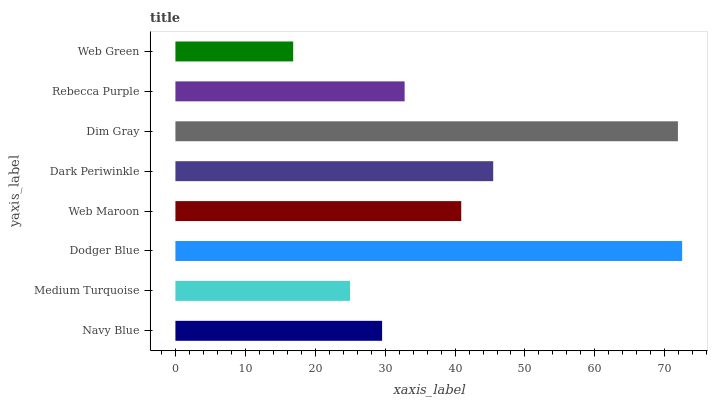Is Web Green the minimum?
Answer yes or no. Yes. Is Dodger Blue the maximum?
Answer yes or no. Yes. Is Medium Turquoise the minimum?
Answer yes or no. No. Is Medium Turquoise the maximum?
Answer yes or no. No. Is Navy Blue greater than Medium Turquoise?
Answer yes or no. Yes. Is Medium Turquoise less than Navy Blue?
Answer yes or no. Yes. Is Medium Turquoise greater than Navy Blue?
Answer yes or no. No. Is Navy Blue less than Medium Turquoise?
Answer yes or no. No. Is Web Maroon the high median?
Answer yes or no. Yes. Is Rebecca Purple the low median?
Answer yes or no. Yes. Is Dodger Blue the high median?
Answer yes or no. No. Is Web Green the low median?
Answer yes or no. No. 